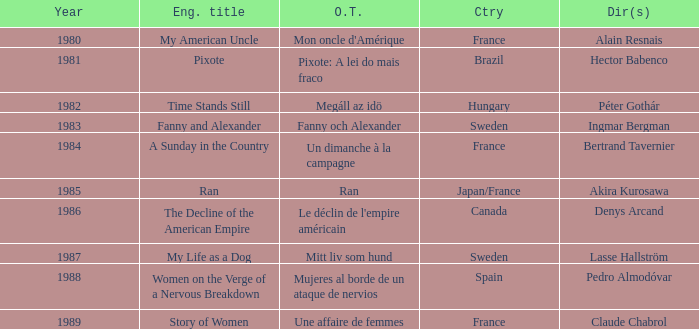What was the original title that was directed by Alain Resnais in France before 1986? Mon oncle d'Amérique. 